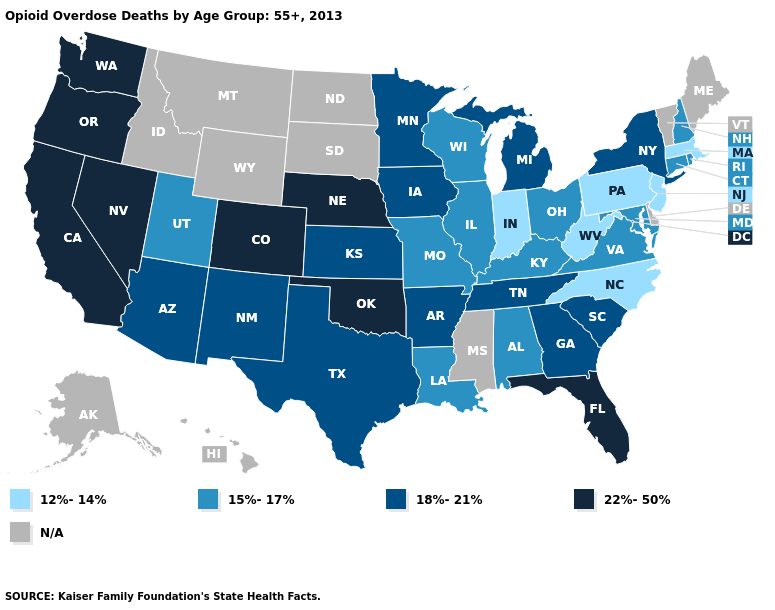What is the value of New Hampshire?
Short answer required. 15%-17%. Does the first symbol in the legend represent the smallest category?
Keep it brief. Yes. Does Colorado have the highest value in the USA?
Write a very short answer. Yes. Which states hav the highest value in the West?
Short answer required. California, Colorado, Nevada, Oregon, Washington. Does the map have missing data?
Concise answer only. Yes. Does New Hampshire have the lowest value in the Northeast?
Be succinct. No. Name the states that have a value in the range 22%-50%?
Short answer required. California, Colorado, Florida, Nebraska, Nevada, Oklahoma, Oregon, Washington. Among the states that border Kentucky , which have the highest value?
Quick response, please. Tennessee. Name the states that have a value in the range N/A?
Keep it brief. Alaska, Delaware, Hawaii, Idaho, Maine, Mississippi, Montana, North Dakota, South Dakota, Vermont, Wyoming. Name the states that have a value in the range 15%-17%?
Short answer required. Alabama, Connecticut, Illinois, Kentucky, Louisiana, Maryland, Missouri, New Hampshire, Ohio, Rhode Island, Utah, Virginia, Wisconsin. Among the states that border Colorado , which have the highest value?
Keep it brief. Nebraska, Oklahoma. Does the first symbol in the legend represent the smallest category?
Answer briefly. Yes. Does the map have missing data?
Keep it brief. Yes. What is the lowest value in the USA?
Concise answer only. 12%-14%. 